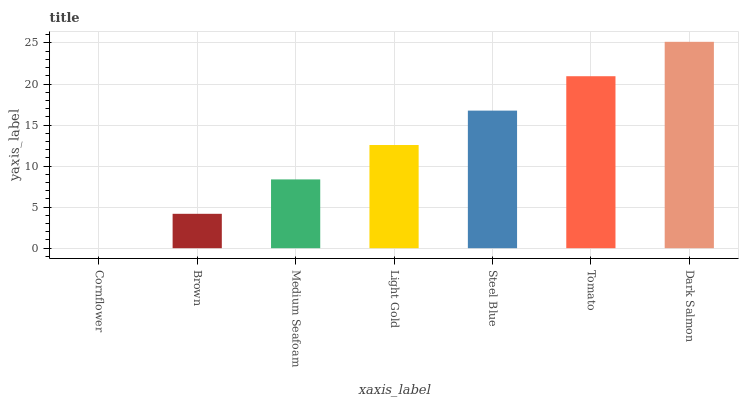Is Cornflower the minimum?
Answer yes or no. Yes. Is Dark Salmon the maximum?
Answer yes or no. Yes. Is Brown the minimum?
Answer yes or no. No. Is Brown the maximum?
Answer yes or no. No. Is Brown greater than Cornflower?
Answer yes or no. Yes. Is Cornflower less than Brown?
Answer yes or no. Yes. Is Cornflower greater than Brown?
Answer yes or no. No. Is Brown less than Cornflower?
Answer yes or no. No. Is Light Gold the high median?
Answer yes or no. Yes. Is Light Gold the low median?
Answer yes or no. Yes. Is Dark Salmon the high median?
Answer yes or no. No. Is Dark Salmon the low median?
Answer yes or no. No. 